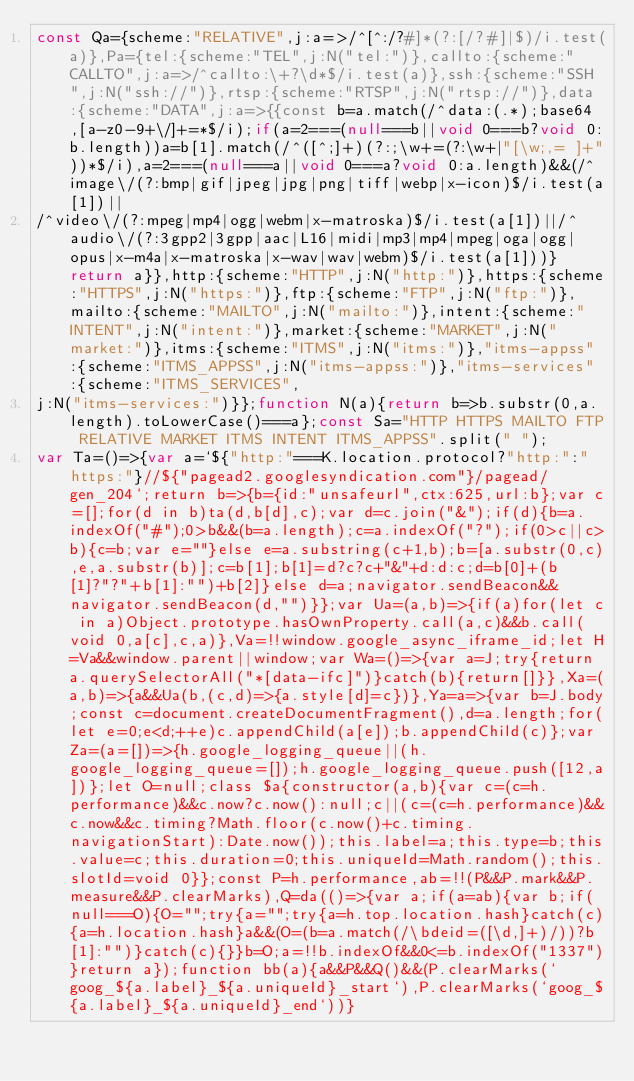Convert code to text. <code><loc_0><loc_0><loc_500><loc_500><_JavaScript_>const Qa={scheme:"RELATIVE",j:a=>/^[^:/?#]*(?:[/?#]|$)/i.test(a)},Pa={tel:{scheme:"TEL",j:N("tel:")},callto:{scheme:"CALLTO",j:a=>/^callto:\+?\d*$/i.test(a)},ssh:{scheme:"SSH",j:N("ssh://")},rtsp:{scheme:"RTSP",j:N("rtsp://")},data:{scheme:"DATA",j:a=>{{const b=a.match(/^data:(.*);base64,[a-z0-9+\/]+=*$/i);if(a=2===(null===b||void 0===b?void 0:b.length))a=b[1].match(/^([^;]+)(?:;\w+=(?:\w+|"[\w;,= ]+"))*$/i),a=2===(null===a||void 0===a?void 0:a.length)&&(/^image\/(?:bmp|gif|jpeg|jpg|png|tiff|webp|x-icon)$/i.test(a[1])|| 
/^video\/(?:mpeg|mp4|ogg|webm|x-matroska)$/i.test(a[1])||/^audio\/(?:3gpp2|3gpp|aac|L16|midi|mp3|mp4|mpeg|oga|ogg|opus|x-m4a|x-matroska|x-wav|wav|webm)$/i.test(a[1]))}return a}},http:{scheme:"HTTP",j:N("http:")},https:{scheme:"HTTPS",j:N("https:")},ftp:{scheme:"FTP",j:N("ftp:")},mailto:{scheme:"MAILTO",j:N("mailto:")},intent:{scheme:"INTENT",j:N("intent:")},market:{scheme:"MARKET",j:N("market:")},itms:{scheme:"ITMS",j:N("itms:")},"itms-appss":{scheme:"ITMS_APPSS",j:N("itms-appss:")},"itms-services":{scheme:"ITMS_SERVICES", 
j:N("itms-services:")}};function N(a){return b=>b.substr(0,a.length).toLowerCase()===a};const Sa="HTTP HTTPS MAILTO FTP RELATIVE MARKET ITMS INTENT ITMS_APPSS".split(" "); 
var Ta=()=>{var a=`${"http:"===K.location.protocol?"http:":"https:"}//${"pagead2.googlesyndication.com"}/pagead/gen_204`;return b=>{b={id:"unsafeurl",ctx:625,url:b};var c=[];for(d in b)ta(d,b[d],c);var d=c.join("&");if(d){b=a.indexOf("#");0>b&&(b=a.length);c=a.indexOf("?");if(0>c||c>b){c=b;var e=""}else e=a.substring(c+1,b);b=[a.substr(0,c),e,a.substr(b)];c=b[1];b[1]=d?c?c+"&"+d:d:c;d=b[0]+(b[1]?"?"+b[1]:"")+b[2]}else d=a;navigator.sendBeacon&&navigator.sendBeacon(d,"")}};var Ua=(a,b)=>{if(a)for(let c in a)Object.prototype.hasOwnProperty.call(a,c)&&b.call(void 0,a[c],c,a)},Va=!!window.google_async_iframe_id;let H=Va&&window.parent||window;var Wa=()=>{var a=J;try{return a.querySelectorAll("*[data-ifc]")}catch(b){return[]}},Xa=(a,b)=>{a&&Ua(b,(c,d)=>{a.style[d]=c})},Ya=a=>{var b=J.body;const c=document.createDocumentFragment(),d=a.length;for(let e=0;e<d;++e)c.appendChild(a[e]);b.appendChild(c)};var Za=(a=[])=>{h.google_logging_queue||(h.google_logging_queue=[]);h.google_logging_queue.push([12,a])};let O=null;class $a{constructor(a,b){var c=(c=h.performance)&&c.now?c.now():null;c||(c=(c=h.performance)&&c.now&&c.timing?Math.floor(c.now()+c.timing.navigationStart):Date.now());this.label=a;this.type=b;this.value=c;this.duration=0;this.uniqueId=Math.random();this.slotId=void 0}};const P=h.performance,ab=!!(P&&P.mark&&P.measure&&P.clearMarks),Q=da(()=>{var a;if(a=ab){var b;if(null===O){O="";try{a="";try{a=h.top.location.hash}catch(c){a=h.location.hash}a&&(O=(b=a.match(/\bdeid=([\d,]+)/))?b[1]:"")}catch(c){}}b=O;a=!!b.indexOf&&0<=b.indexOf("1337")}return a});function bb(a){a&&P&&Q()&&(P.clearMarks(`goog_${a.label}_${a.uniqueId}_start`),P.clearMarks(`goog_${a.label}_${a.uniqueId}_end`))} </code> 